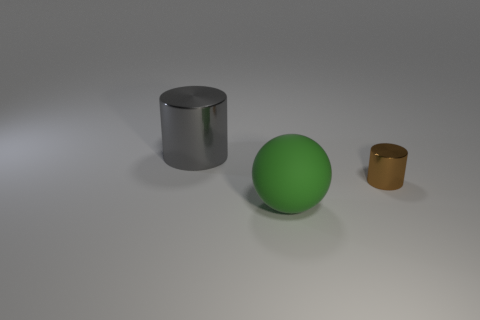The big object behind the small brown metallic thing is what color?
Your answer should be compact. Gray. The large object that is in front of the cylinder that is to the right of the big metal cylinder is made of what material?
Make the answer very short. Rubber. Are there any other blue balls of the same size as the sphere?
Provide a short and direct response. No. How many objects are either metallic objects that are behind the brown object or cylinders that are on the left side of the big sphere?
Your response must be concise. 1. There is a thing on the right side of the rubber object; does it have the same size as the cylinder on the left side of the brown cylinder?
Ensure brevity in your answer.  No. Are there any green objects that are behind the large thing behind the big sphere?
Offer a terse response. No. There is a green thing; how many large metal cylinders are behind it?
Provide a short and direct response. 1. How many other objects are the same color as the tiny metallic thing?
Give a very brief answer. 0. Are there fewer green rubber things left of the gray thing than brown things that are to the right of the brown cylinder?
Provide a succinct answer. No. How many things are either large things behind the big matte object or green things?
Provide a short and direct response. 2. 